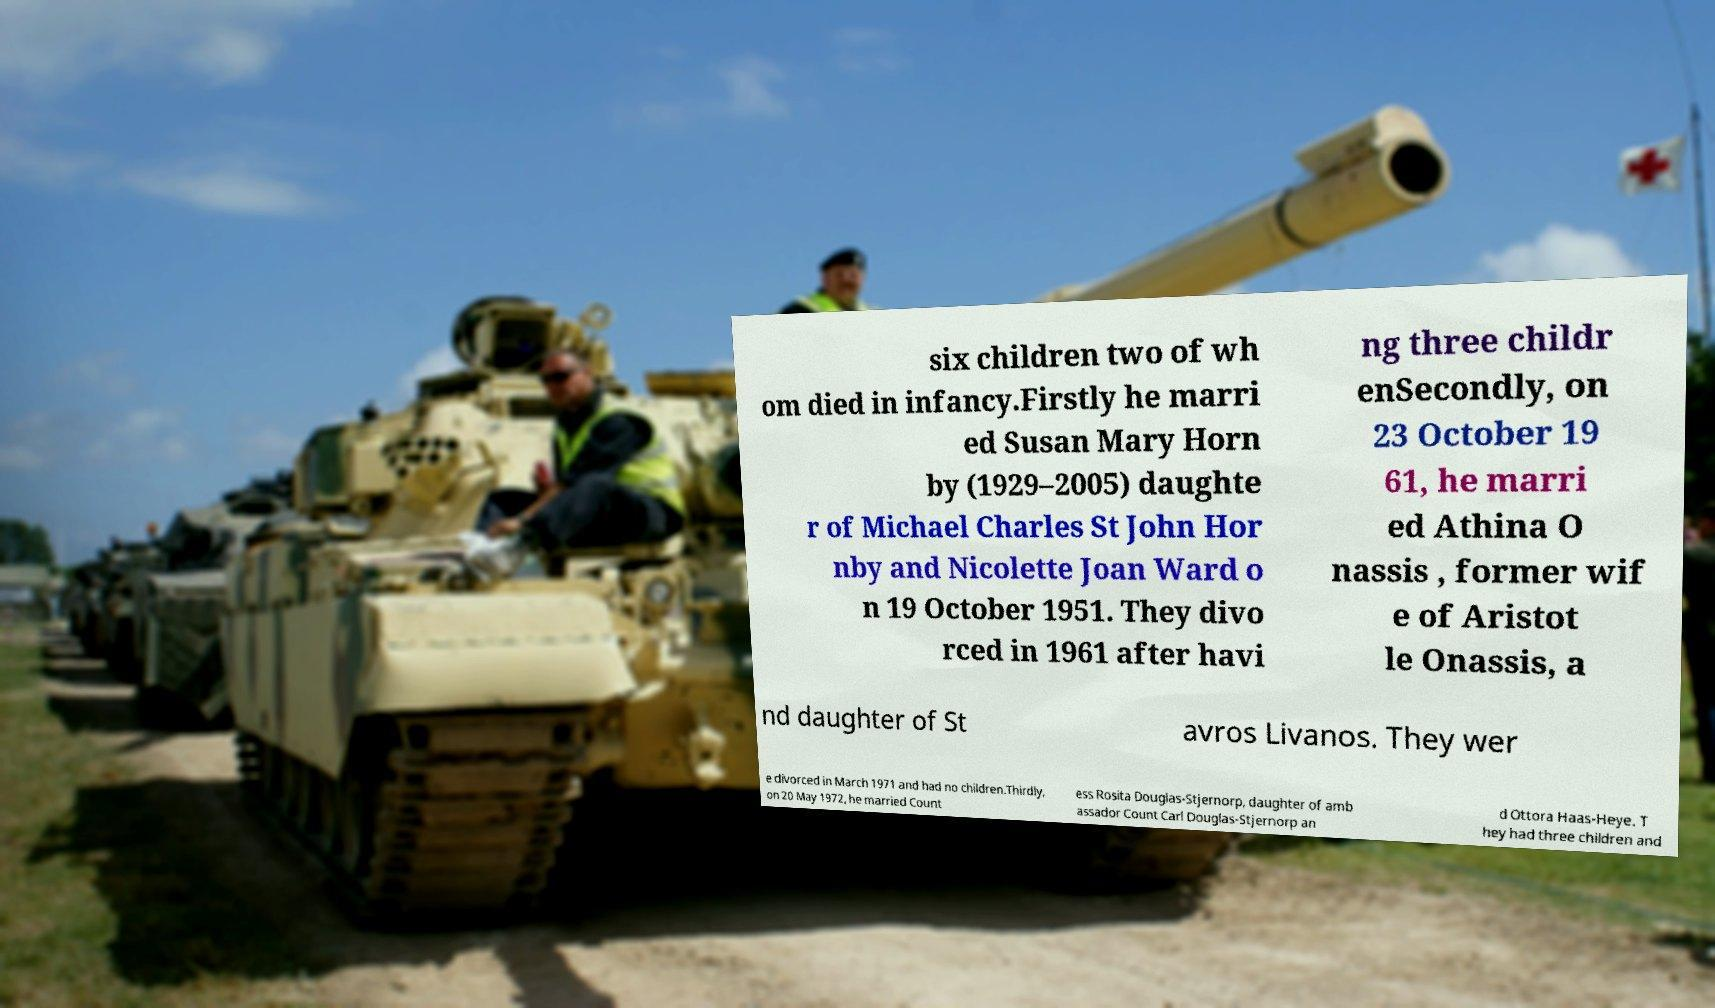There's text embedded in this image that I need extracted. Can you transcribe it verbatim? six children two of wh om died in infancy.Firstly he marri ed Susan Mary Horn by (1929–2005) daughte r of Michael Charles St John Hor nby and Nicolette Joan Ward o n 19 October 1951. They divo rced in 1961 after havi ng three childr enSecondly, on 23 October 19 61, he marri ed Athina O nassis , former wif e of Aristot le Onassis, a nd daughter of St avros Livanos. They wer e divorced in March 1971 and had no children.Thirdly, on 20 May 1972, he married Count ess Rosita Douglas-Stjernorp, daughter of amb assador Count Carl Douglas-Stjernorp an d Ottora Haas-Heye. T hey had three children and 